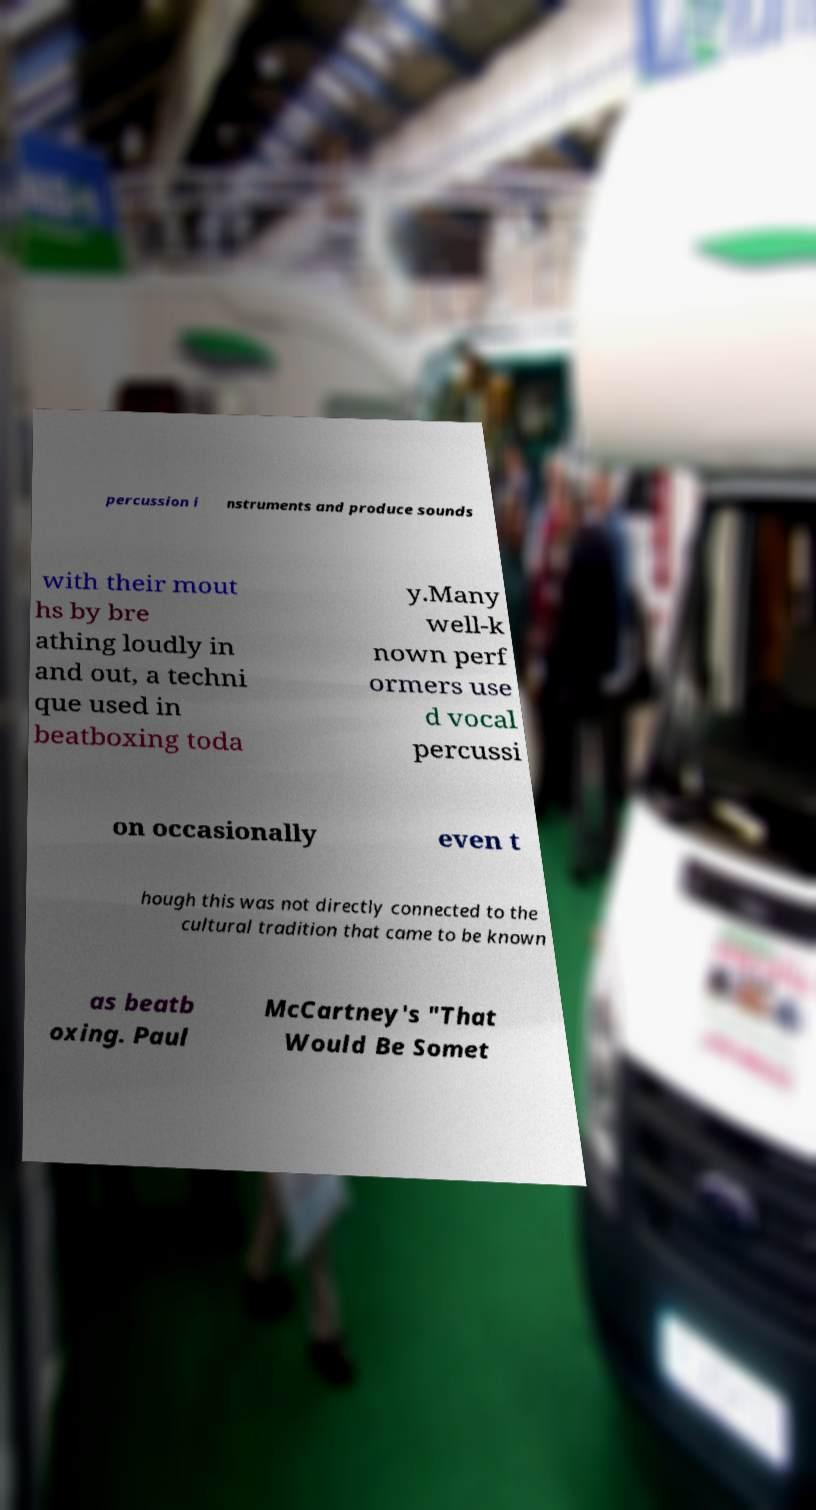Could you extract and type out the text from this image? percussion i nstruments and produce sounds with their mout hs by bre athing loudly in and out, a techni que used in beatboxing toda y.Many well-k nown perf ormers use d vocal percussi on occasionally even t hough this was not directly connected to the cultural tradition that came to be known as beatb oxing. Paul McCartney's "That Would Be Somet 